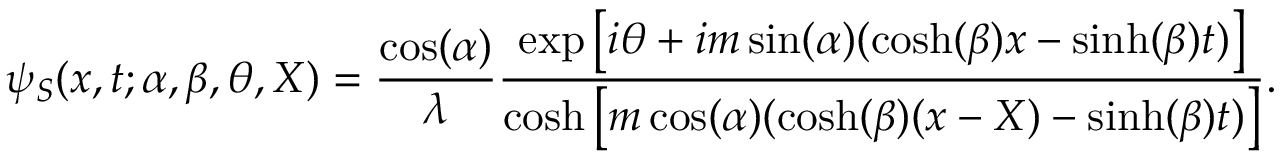Convert formula to latex. <formula><loc_0><loc_0><loc_500><loc_500>\psi _ { S } ( x , t ; \alpha , \beta , \theta , X ) = \frac { \cos ( \alpha ) } { \lambda } \frac { \exp \left [ i \theta + i m \sin ( \alpha ) ( \cosh ( \beta ) x - \sinh ( \beta ) t ) \right ] } { \cosh \left [ m \cos ( \alpha ) ( \cosh ( \beta ) ( x - X ) - \sinh ( \beta ) t ) \right ] } .</formula> 